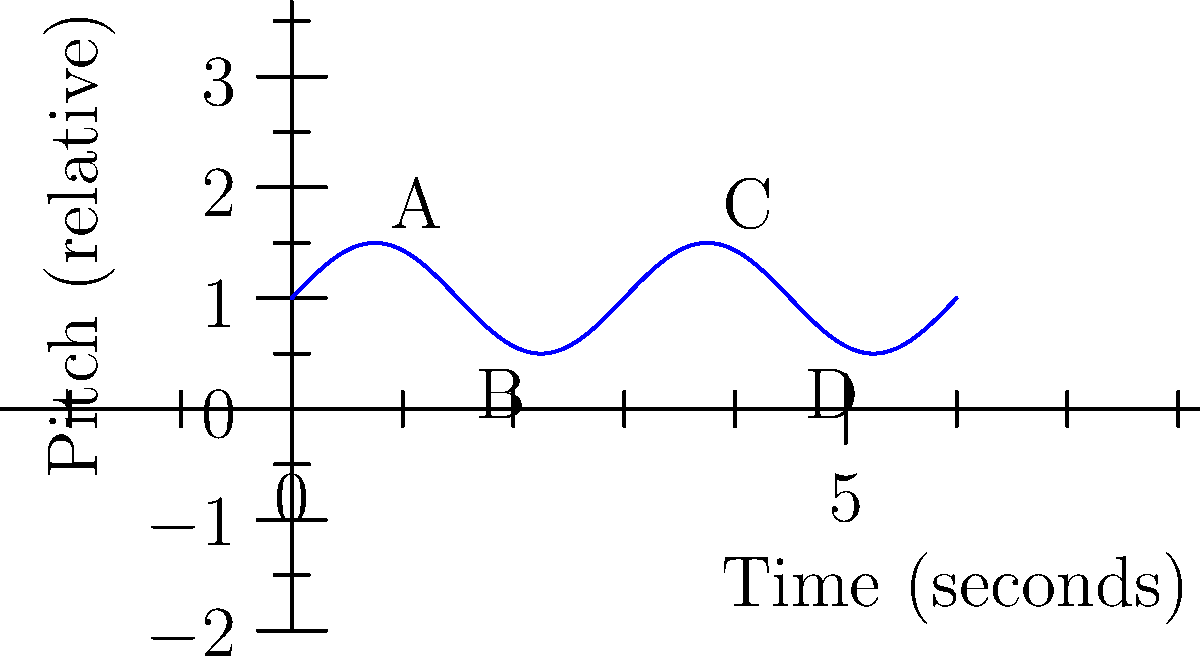As a pop singer, you're analyzing a graph of your vocal pitch variations during a performance. The sine wave represents your pitch over time. What is the period of this pitch variation in seconds? To find the period of the sine wave, we need to determine the time it takes for one complete cycle. Let's approach this step-by-step:

1. In a sine wave, one complete cycle occurs between two consecutive peaks or troughs.

2. Looking at the graph, we can see that there are two complete cycles within the 6-second timeframe.

3. The points labeled A, B, C, and D represent the peaks and troughs of the wave.

4. The distance between A and C represents one complete cycle.

5. We can calculate this distance:
   - A occurs at approximately 0.75 seconds
   - C occurs at approximately 3.75 seconds
   
6. The time difference between A and C is:
   $3.75 - 0.75 = 3$ seconds

7. This 3-second interval represents one complete cycle, which is the period of the sine wave.

Therefore, the period of the pitch variation is 3 seconds.
Answer: 3 seconds 